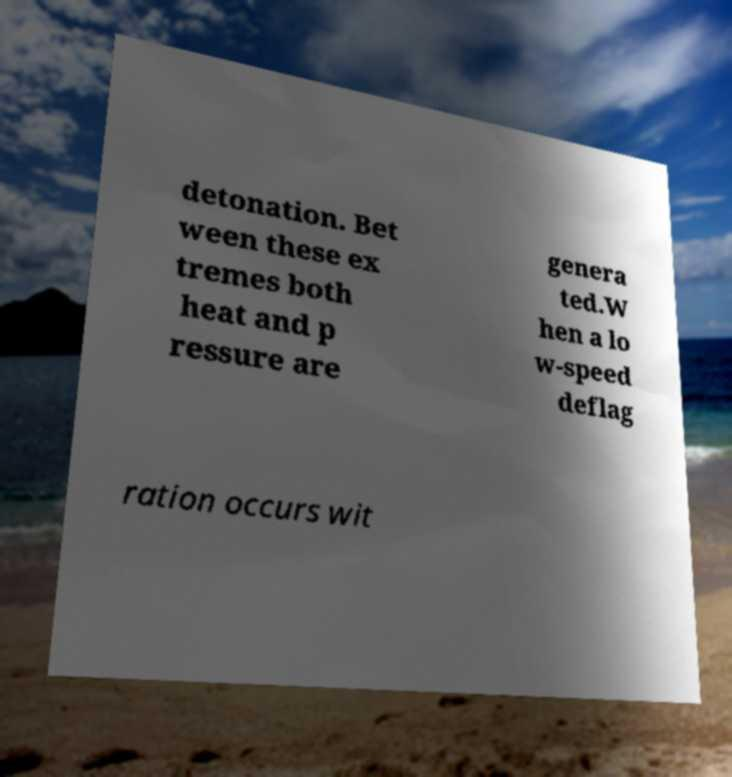For documentation purposes, I need the text within this image transcribed. Could you provide that? detonation. Bet ween these ex tremes both heat and p ressure are genera ted.W hen a lo w-speed deflag ration occurs wit 